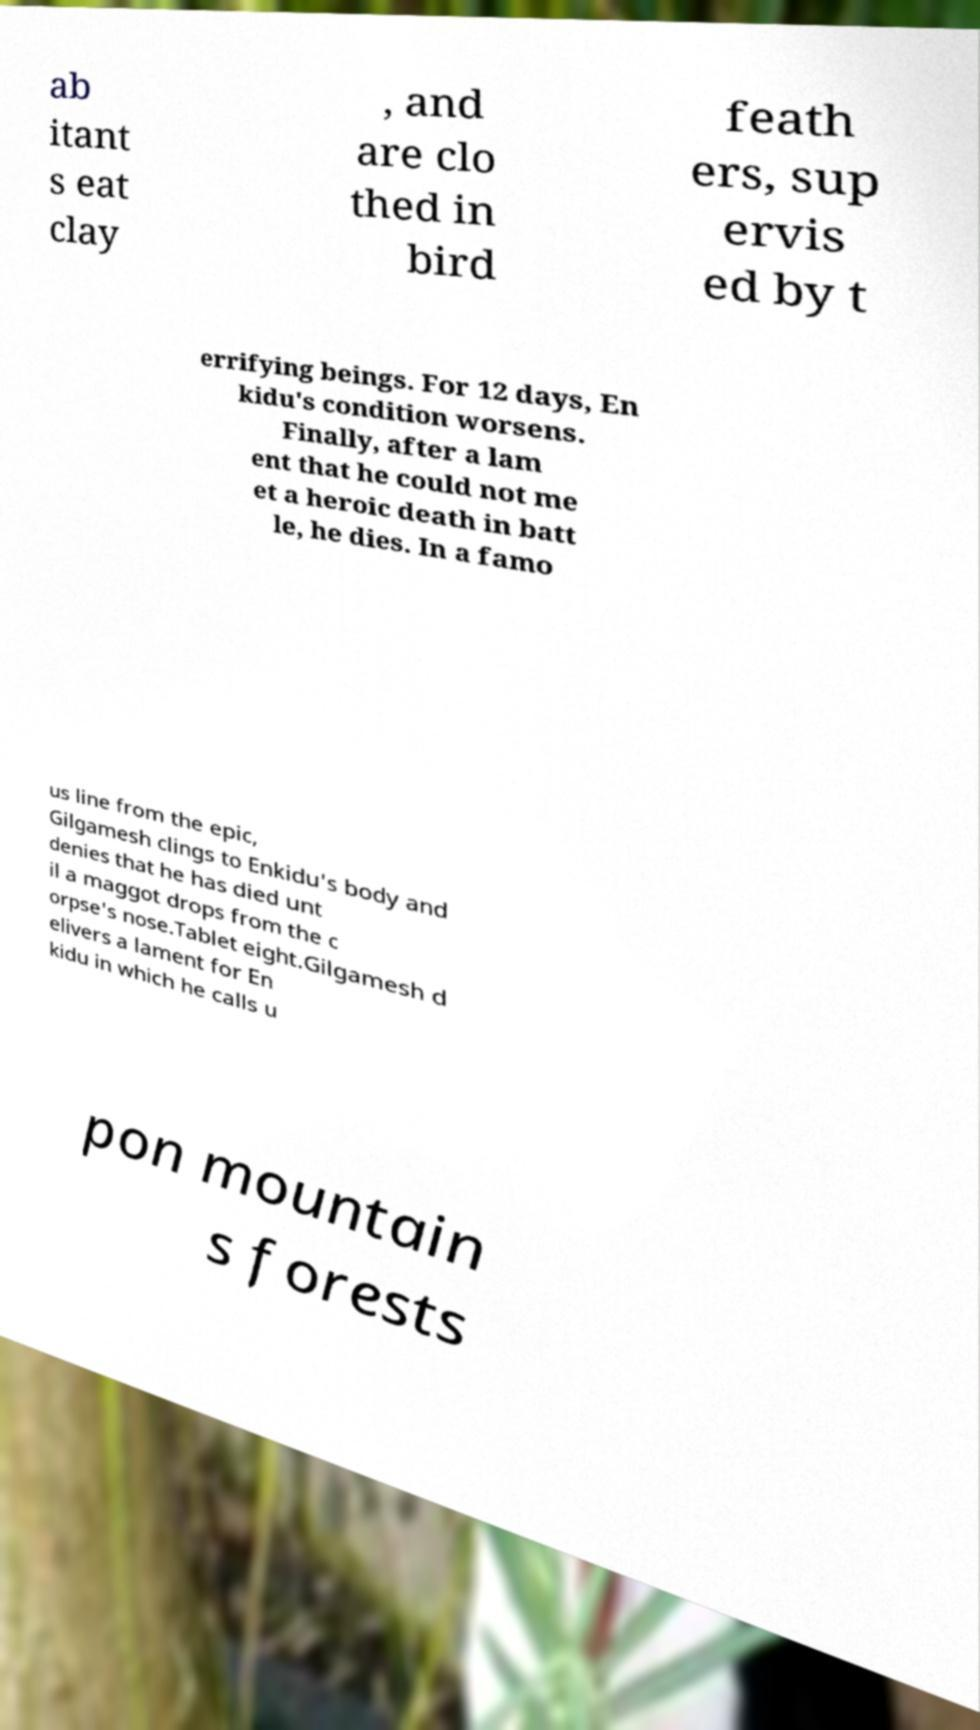Can you accurately transcribe the text from the provided image for me? ab itant s eat clay , and are clo thed in bird feath ers, sup ervis ed by t errifying beings. For 12 days, En kidu's condition worsens. Finally, after a lam ent that he could not me et a heroic death in batt le, he dies. In a famo us line from the epic, Gilgamesh clings to Enkidu's body and denies that he has died unt il a maggot drops from the c orpse's nose.Tablet eight.Gilgamesh d elivers a lament for En kidu in which he calls u pon mountain s forests 